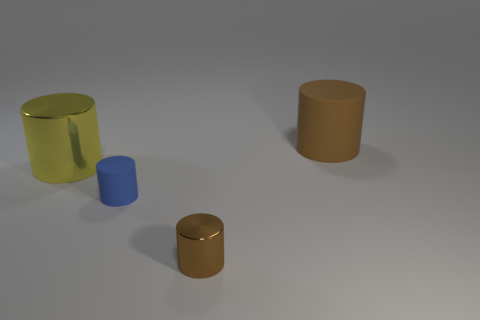What material is the blue thing that is the same shape as the large brown thing?
Ensure brevity in your answer.  Rubber. Is there anything else that has the same size as the yellow shiny cylinder?
Provide a succinct answer. Yes. Are there more rubber cylinders than yellow metallic cylinders?
Give a very brief answer. Yes. There is a cylinder that is in front of the yellow shiny cylinder and to the left of the small brown thing; what size is it?
Make the answer very short. Small. What is the shape of the large yellow metal object?
Ensure brevity in your answer.  Cylinder. What number of other big yellow shiny things are the same shape as the large yellow thing?
Your answer should be very brief. 0. Is the number of metallic cylinders that are behind the big metal thing less than the number of tiny blue objects that are on the right side of the big brown rubber cylinder?
Make the answer very short. No. There is a rubber cylinder to the left of the tiny metallic object; what number of small things are on the right side of it?
Make the answer very short. 1. Are there any rubber objects?
Keep it short and to the point. Yes. Are there any big objects made of the same material as the yellow cylinder?
Your answer should be very brief. No. 